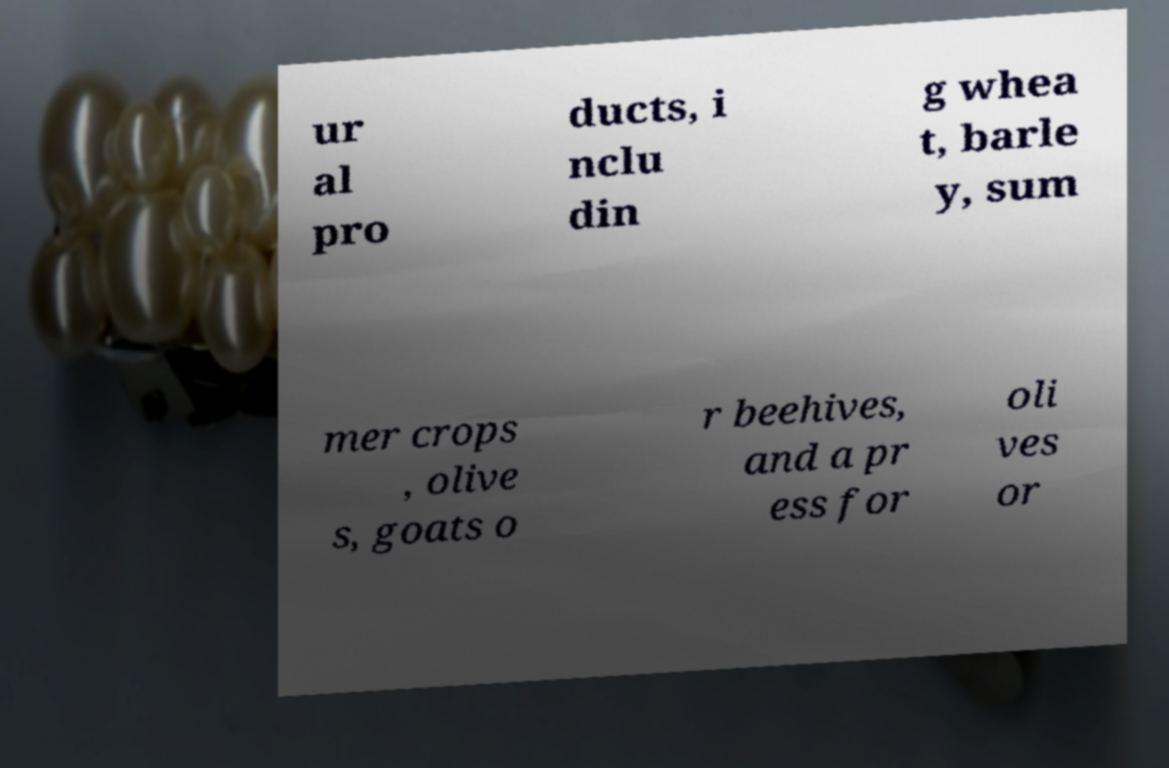Could you assist in decoding the text presented in this image and type it out clearly? ur al pro ducts, i nclu din g whea t, barle y, sum mer crops , olive s, goats o r beehives, and a pr ess for oli ves or 